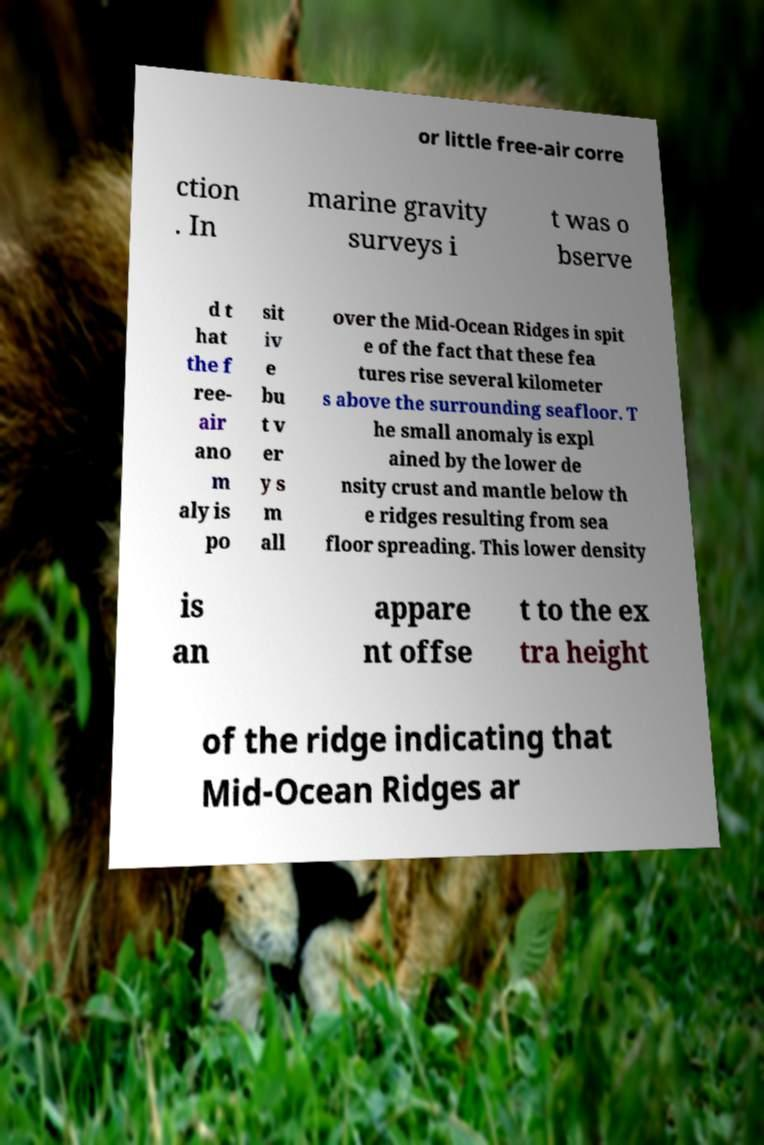Please read and relay the text visible in this image. What does it say? or little free-air corre ction . In marine gravity surveys i t was o bserve d t hat the f ree- air ano m aly is po sit iv e bu t v er y s m all over the Mid-Ocean Ridges in spit e of the fact that these fea tures rise several kilometer s above the surrounding seafloor. T he small anomaly is expl ained by the lower de nsity crust and mantle below th e ridges resulting from sea floor spreading. This lower density is an appare nt offse t to the ex tra height of the ridge indicating that Mid-Ocean Ridges ar 